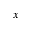<formula> <loc_0><loc_0><loc_500><loc_500>x</formula> 